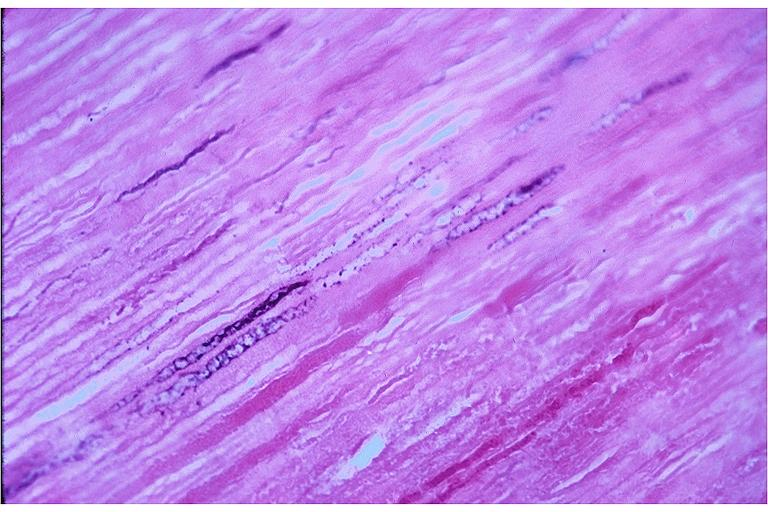does this image show caries?
Answer the question using a single word or phrase. Yes 